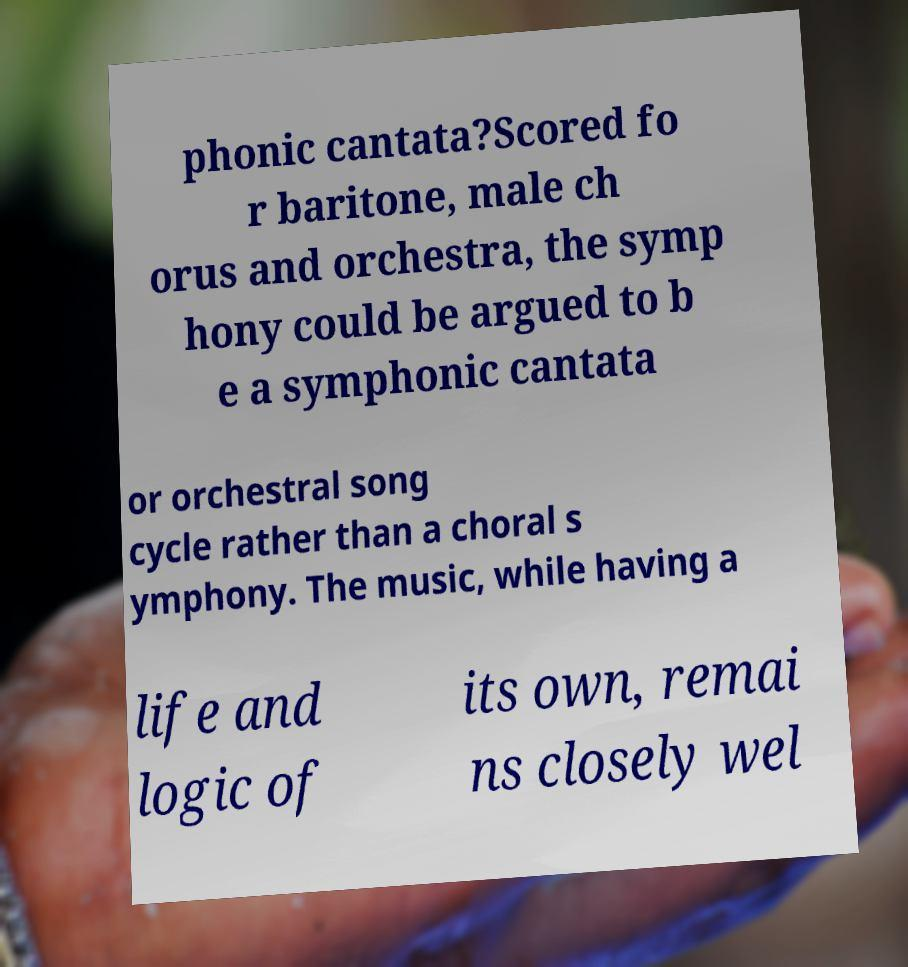Could you assist in decoding the text presented in this image and type it out clearly? phonic cantata?Scored fo r baritone, male ch orus and orchestra, the symp hony could be argued to b e a symphonic cantata or orchestral song cycle rather than a choral s ymphony. The music, while having a life and logic of its own, remai ns closely wel 